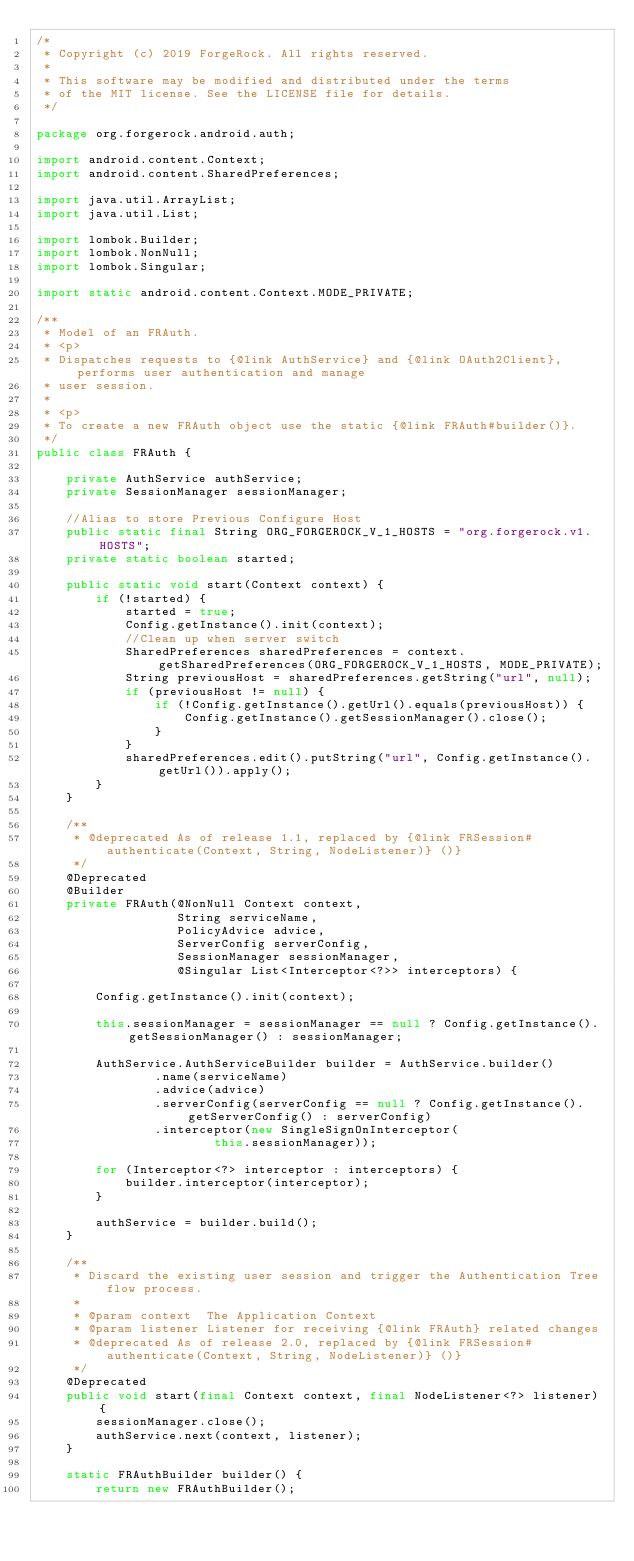<code> <loc_0><loc_0><loc_500><loc_500><_Java_>/*
 * Copyright (c) 2019 ForgeRock. All rights reserved.
 *
 * This software may be modified and distributed under the terms
 * of the MIT license. See the LICENSE file for details.
 */

package org.forgerock.android.auth;

import android.content.Context;
import android.content.SharedPreferences;

import java.util.ArrayList;
import java.util.List;

import lombok.Builder;
import lombok.NonNull;
import lombok.Singular;

import static android.content.Context.MODE_PRIVATE;

/**
 * Model of an FRAuth.
 * <p>
 * Dispatches requests to {@link AuthService} and {@link OAuth2Client}, performs user authentication and manage
 * user session.
 *
 * <p>
 * To create a new FRAuth object use the static {@link FRAuth#builder()}.
 */
public class FRAuth {

    private AuthService authService;
    private SessionManager sessionManager;

    //Alias to store Previous Configure Host
    public static final String ORG_FORGEROCK_V_1_HOSTS = "org.forgerock.v1.HOSTS";
    private static boolean started;

    public static void start(Context context) {
        if (!started) {
            started = true;
            Config.getInstance().init(context);
            //Clean up when server switch
            SharedPreferences sharedPreferences = context.getSharedPreferences(ORG_FORGEROCK_V_1_HOSTS, MODE_PRIVATE);
            String previousHost = sharedPreferences.getString("url", null);
            if (previousHost != null) {
                if (!Config.getInstance().getUrl().equals(previousHost)) {
                    Config.getInstance().getSessionManager().close();
                }
            }
            sharedPreferences.edit().putString("url", Config.getInstance().getUrl()).apply();
        }
    }

    /**
     * @deprecated As of release 1.1, replaced by {@link FRSession#authenticate(Context, String, NodeListener)} ()}
     */
    @Deprecated
    @Builder
    private FRAuth(@NonNull Context context,
                   String serviceName,
                   PolicyAdvice advice,
                   ServerConfig serverConfig,
                   SessionManager sessionManager,
                   @Singular List<Interceptor<?>> interceptors) {

        Config.getInstance().init(context);

        this.sessionManager = sessionManager == null ? Config.getInstance().getSessionManager() : sessionManager;

        AuthService.AuthServiceBuilder builder = AuthService.builder()
                .name(serviceName)
                .advice(advice)
                .serverConfig(serverConfig == null ? Config.getInstance().getServerConfig() : serverConfig)
                .interceptor(new SingleSignOnInterceptor(
                        this.sessionManager));

        for (Interceptor<?> interceptor : interceptors) {
            builder.interceptor(interceptor);
        }

        authService = builder.build();
    }

    /**
     * Discard the existing user session and trigger the Authentication Tree flow process.
     *
     * @param context  The Application Context
     * @param listener Listener for receiving {@link FRAuth} related changes
     * @deprecated As of release 2.0, replaced by {@link FRSession#authenticate(Context, String, NodeListener)} ()}
     */
    @Deprecated
    public void start(final Context context, final NodeListener<?> listener) {
        sessionManager.close();
        authService.next(context, listener);
    }

    static FRAuthBuilder builder() {
        return new FRAuthBuilder();</code> 